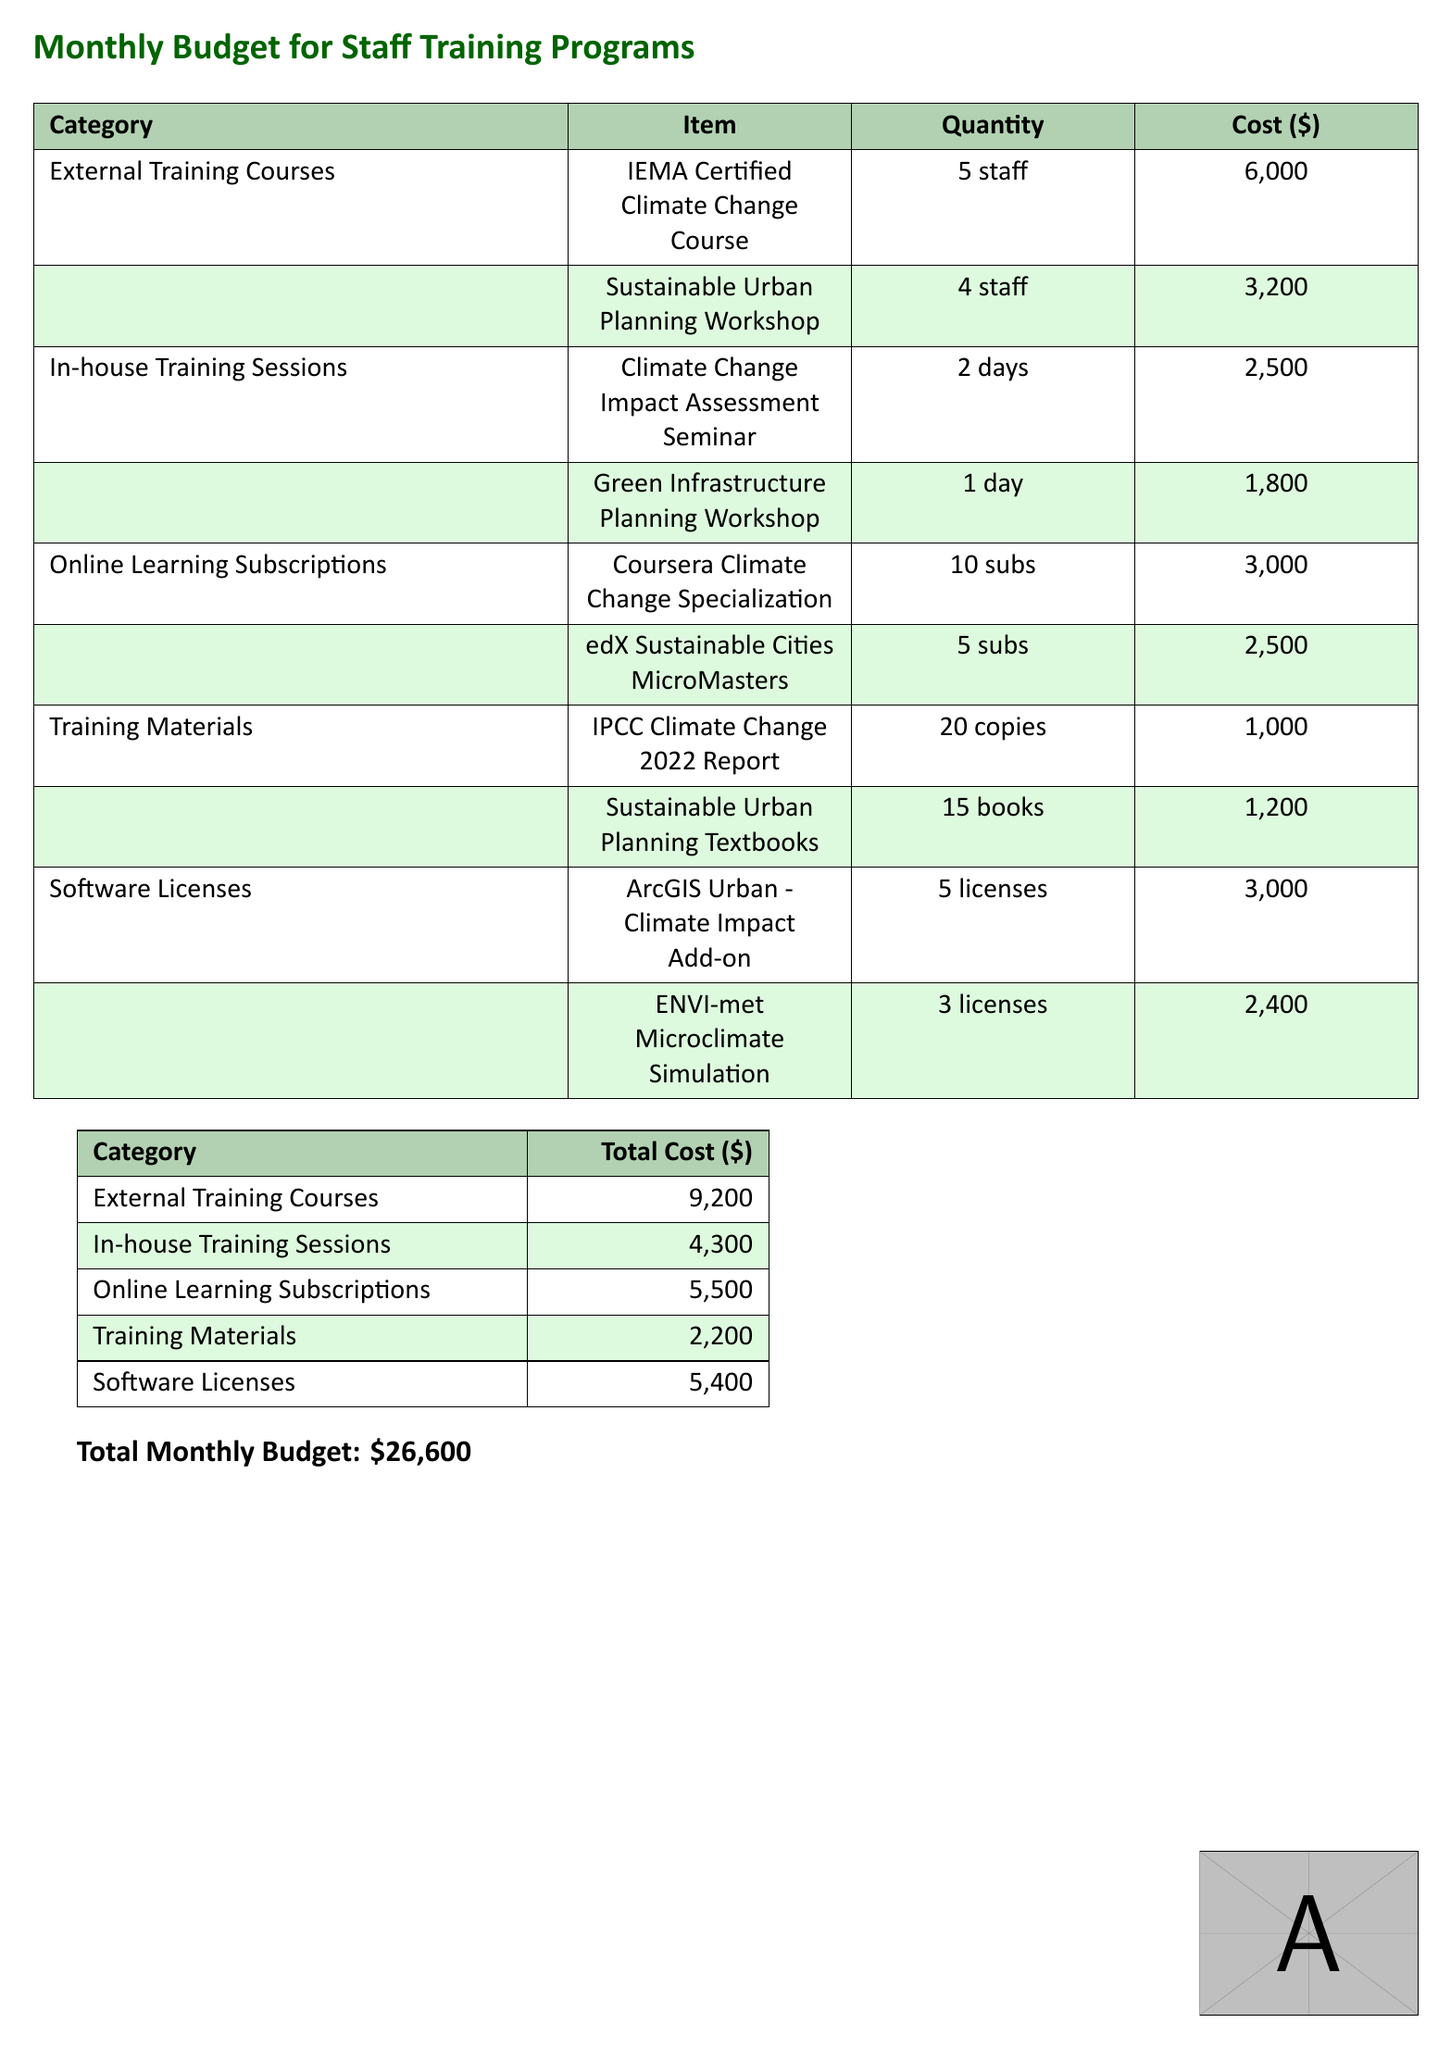What is the total monthly budget? The total monthly budget is provided at the bottom of the document, which adds up all the costs listed.
Answer: $26,600 How many licenses are allocated for the ArcGIS Urban - Climate Impact Add-on? The document specifies the quantity for this software license under the "Software Licenses" category.
Answer: 5 licenses What is the cost of the Sustainable Urban Planning Workshop? The cost for this training item is mentioned in the "External Training Courses" section.
Answer: $3,200 Which training category has the highest total cost? The category with the highest total cost is identified in the second table by comparing the total costs of each category.
Answer: External Training Courses How many staff are included in the IEMA Certified Climate Change Course? The number of staff participating in this course is indicated in the "External Training Courses" section.
Answer: 5 staff What is the cost of the online learning subscription for the Coursera Climate Change Specialization? This cost is detailed in the "Online Learning Subscriptions" category.
Answer: $3,000 Which item has the lowest cost in the Training Materials category? The costs of items listed under the "Training Materials" category can be compared to determine which is the lowest.
Answer: $1,000 What is the quantity of Sustainable Urban Planning Textbooks purchased? This quantity is specified in the "Training Materials" section.
Answer: 15 books What is the total cost for In-house Training Sessions? The total cost for this category is calculated by adding the costs of all items listed under "In-house Training Sessions."
Answer: $4,300 